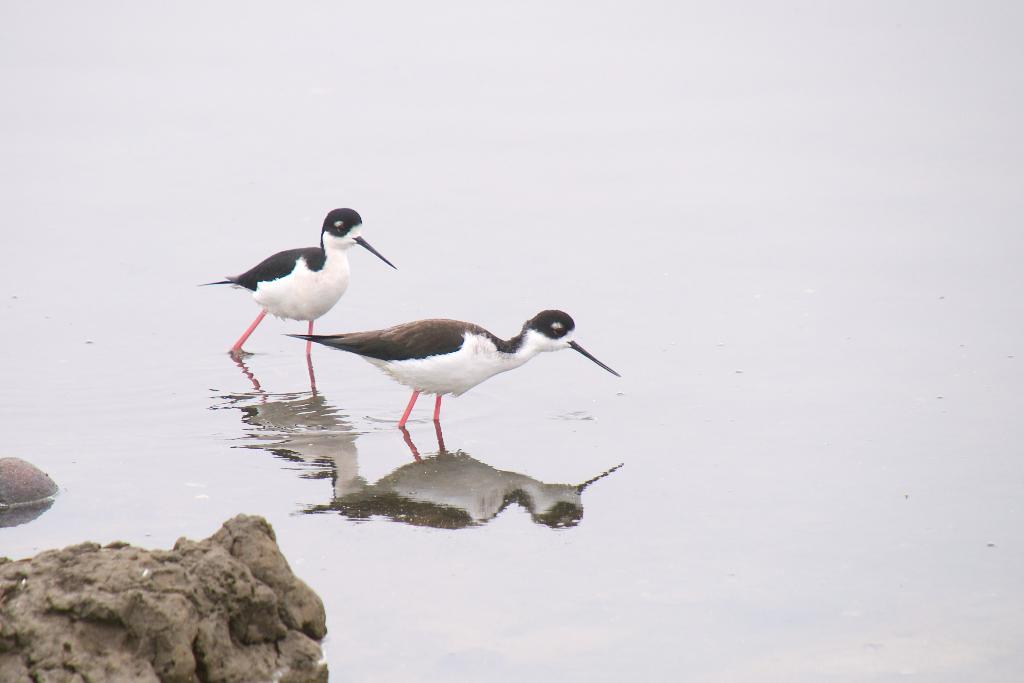What type of animals can be seen in the image? There are birds in the image. What is the primary element in which the birds are situated? The birds are situated in water. Can you describe the reflection of the birds in the image? The birds are reflected on the water. What type of scent can be detected from the snail in the image? There is no snail present in the image, so it is not possible to detect any scent. 